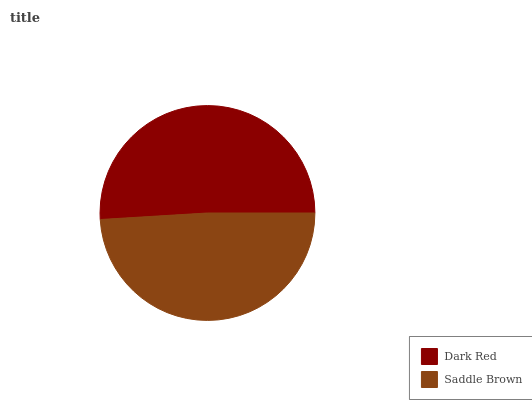Is Saddle Brown the minimum?
Answer yes or no. Yes. Is Dark Red the maximum?
Answer yes or no. Yes. Is Saddle Brown the maximum?
Answer yes or no. No. Is Dark Red greater than Saddle Brown?
Answer yes or no. Yes. Is Saddle Brown less than Dark Red?
Answer yes or no. Yes. Is Saddle Brown greater than Dark Red?
Answer yes or no. No. Is Dark Red less than Saddle Brown?
Answer yes or no. No. Is Dark Red the high median?
Answer yes or no. Yes. Is Saddle Brown the low median?
Answer yes or no. Yes. Is Saddle Brown the high median?
Answer yes or no. No. Is Dark Red the low median?
Answer yes or no. No. 